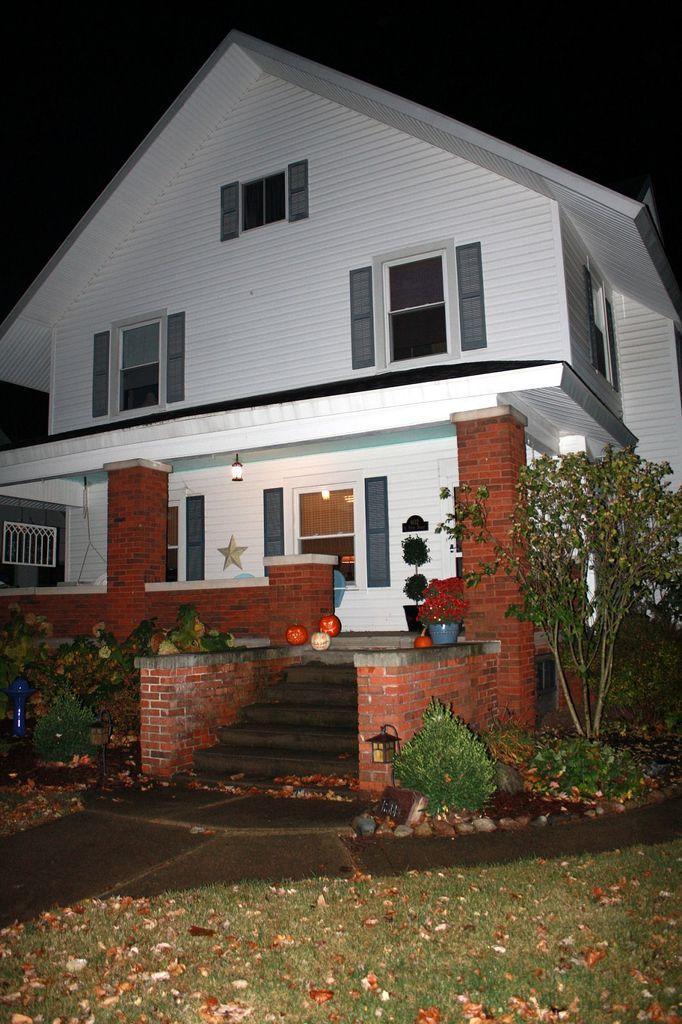Could you give a brief overview of what you see in this image? In the image we can see it is a building. It has four windows. On the front there is grass and stairs and small bolls. On the right side there is a plant. 